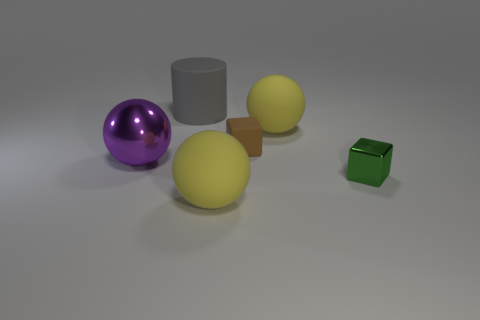Add 2 large purple metallic spheres. How many objects exist? 8 Subtract all cubes. How many objects are left? 4 Add 6 rubber cylinders. How many rubber cylinders exist? 7 Subtract 0 green balls. How many objects are left? 6 Subtract all cylinders. Subtract all large red metallic spheres. How many objects are left? 5 Add 4 brown matte things. How many brown matte things are left? 5 